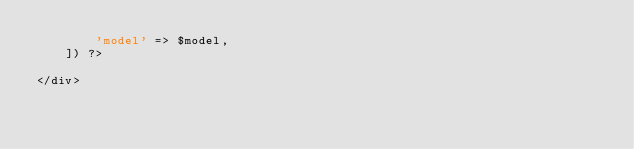Convert code to text. <code><loc_0><loc_0><loc_500><loc_500><_PHP_>        'model' => $model,
    ]) ?>

</div>
</code> 